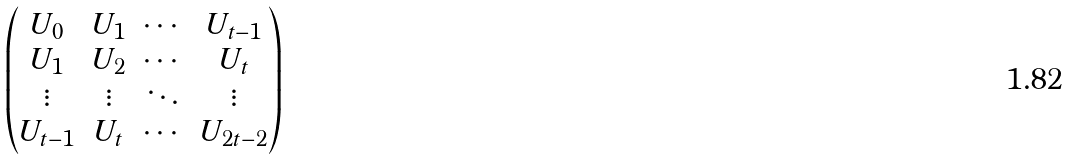Convert formula to latex. <formula><loc_0><loc_0><loc_500><loc_500>\begin{pmatrix} U _ { 0 } & U _ { 1 } & \cdots & U _ { t - 1 } \\ U _ { 1 } & U _ { 2 } & \cdots & U _ { t } \\ \vdots & \vdots & \ddots & \vdots \\ U _ { t - 1 } & U _ { t } & \cdots & U _ { 2 t - 2 } \end{pmatrix}</formula> 